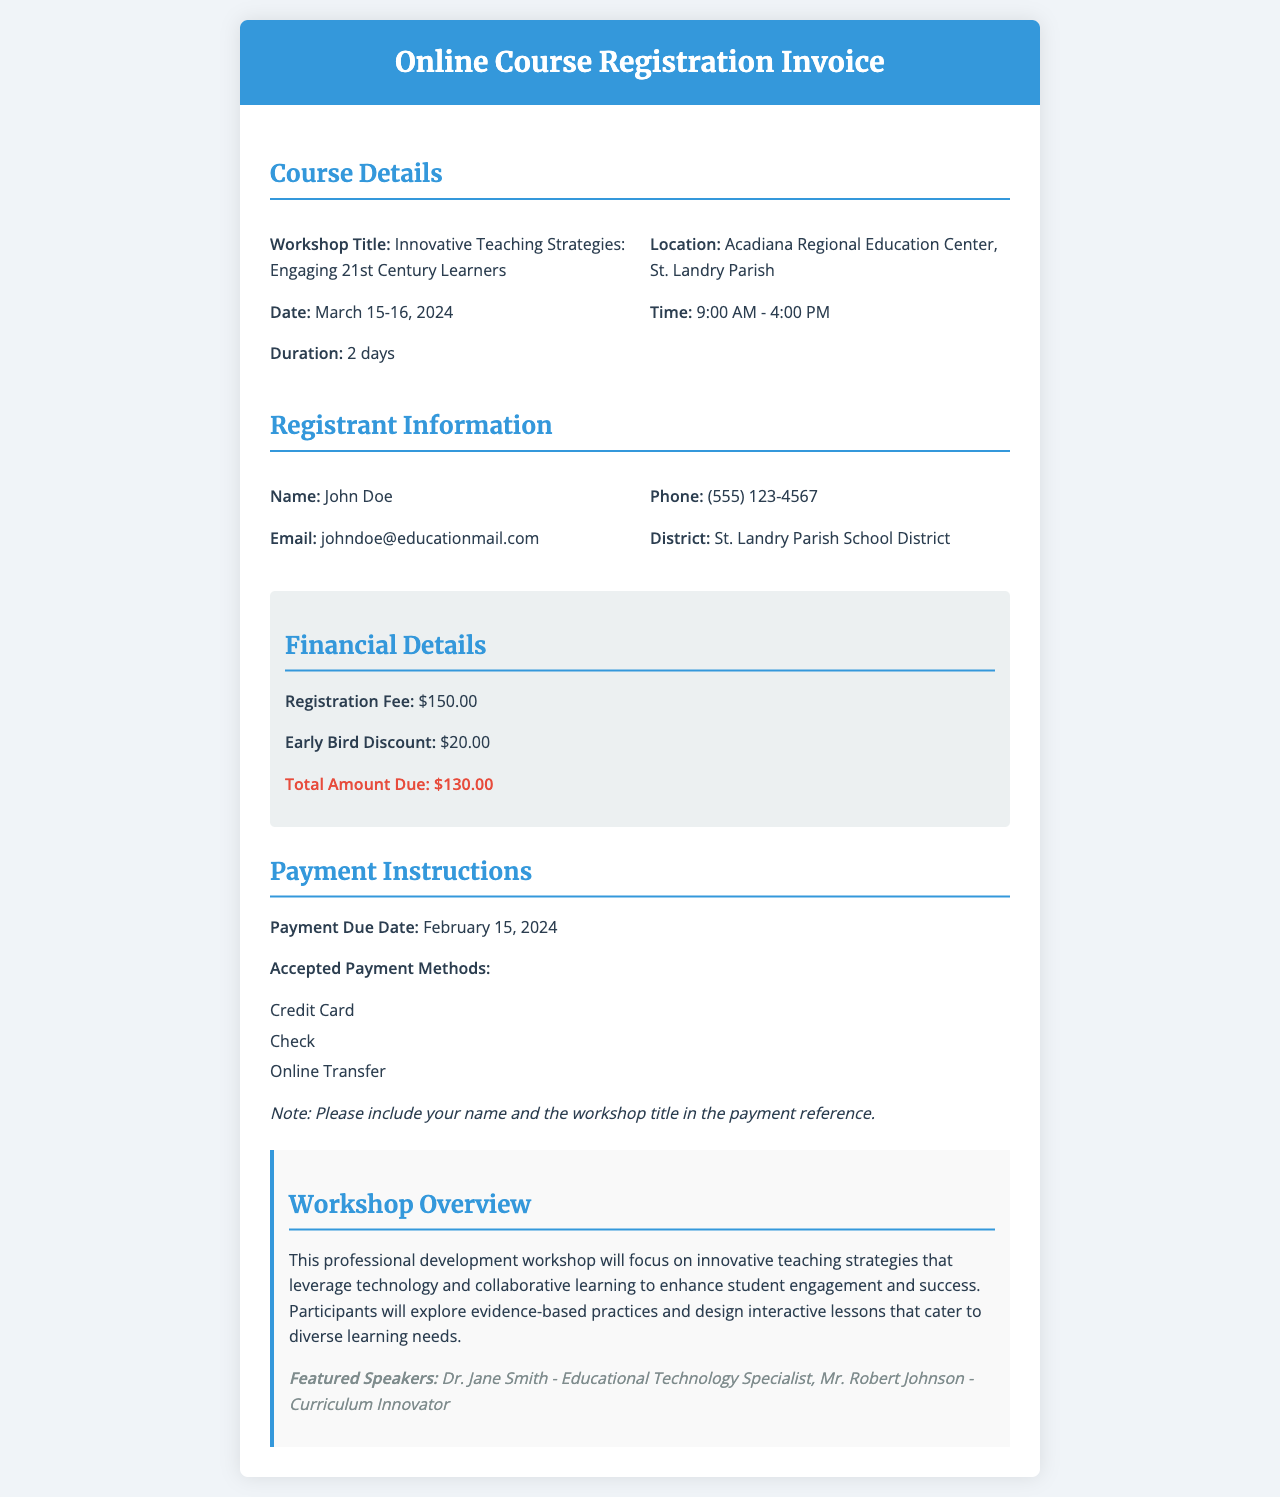What is the workshop title? The workshop title is the main subject of the course mentioned in the document, which is "Innovative Teaching Strategies: Engaging 21st Century Learners."
Answer: Innovative Teaching Strategies: Engaging 21st Century Learners What are the dates of the workshop? The dates of the workshop indicate when it will take place, which is March 15-16, 2024.
Answer: March 15-16, 2024 What is the registration fee? The registration fee is the amount charged to participate in the workshop, which is listed as $150.00.
Answer: $150.00 When is the payment due date? The payment due date tells participants by when they need to pay, which is February 15, 2024.
Answer: February 15, 2024 Who are the featured speakers? The featured speakers provide insight into who will be leading the workshop, which includes Dr. Jane Smith and Mr. Robert Johnson.
Answer: Dr. Jane Smith - Educational Technology Specialist, Mr. Robert Johnson - Curriculum Innovator What is the total amount due after the early bird discount? The total amount due is calculated by subtracting the early bird discount from the registration fee, resulting in $130.00.
Answer: $130.00 What is the location of the workshop? The location indicates where the workshop will be held, which is at the Acadiana Regional Education Center, St. Landry Parish.
Answer: Acadiana Regional Education Center, St. Landry Parish What is emphasized in the workshop overview? The workshop overview focuses on key themes or skills discussed in the workshop, which includes innovative teaching strategies that leverage technology and collaborative learning.
Answer: Innovative teaching strategies that leverage technology and collaborative learning What are the accepted payment methods? The accepted payment methods outline how participants can make their payments, including Credit Card, Check, and Online Transfer.
Answer: Credit Card, Check, Online Transfer 